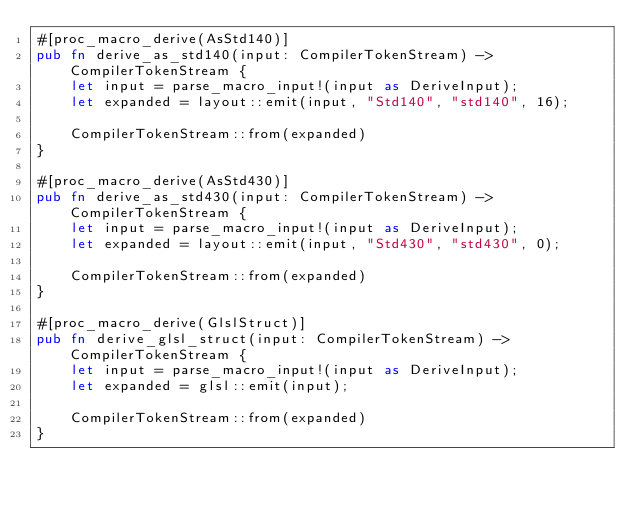Convert code to text. <code><loc_0><loc_0><loc_500><loc_500><_Rust_>#[proc_macro_derive(AsStd140)]
pub fn derive_as_std140(input: CompilerTokenStream) -> CompilerTokenStream {
    let input = parse_macro_input!(input as DeriveInput);
    let expanded = layout::emit(input, "Std140", "std140", 16);

    CompilerTokenStream::from(expanded)
}

#[proc_macro_derive(AsStd430)]
pub fn derive_as_std430(input: CompilerTokenStream) -> CompilerTokenStream {
    let input = parse_macro_input!(input as DeriveInput);
    let expanded = layout::emit(input, "Std430", "std430", 0);

    CompilerTokenStream::from(expanded)
}

#[proc_macro_derive(GlslStruct)]
pub fn derive_glsl_struct(input: CompilerTokenStream) -> CompilerTokenStream {
    let input = parse_macro_input!(input as DeriveInput);
    let expanded = glsl::emit(input);

    CompilerTokenStream::from(expanded)
}
</code> 